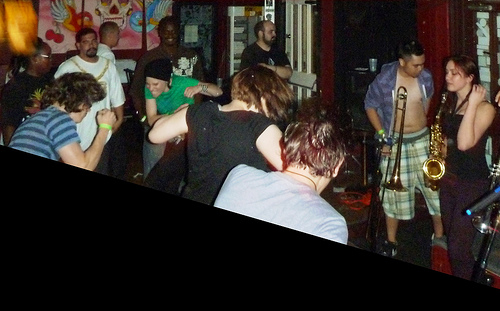<image>
Is the bracelet on the man? Yes. Looking at the image, I can see the bracelet is positioned on top of the man, with the man providing support. 